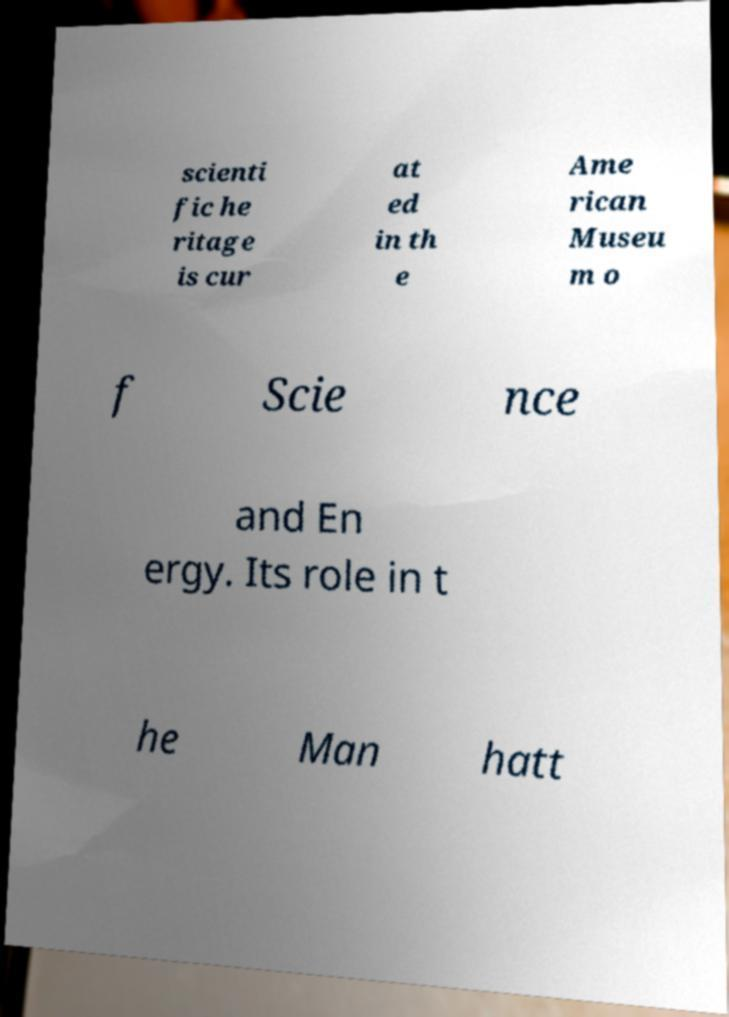There's text embedded in this image that I need extracted. Can you transcribe it verbatim? scienti fic he ritage is cur at ed in th e Ame rican Museu m o f Scie nce and En ergy. Its role in t he Man hatt 